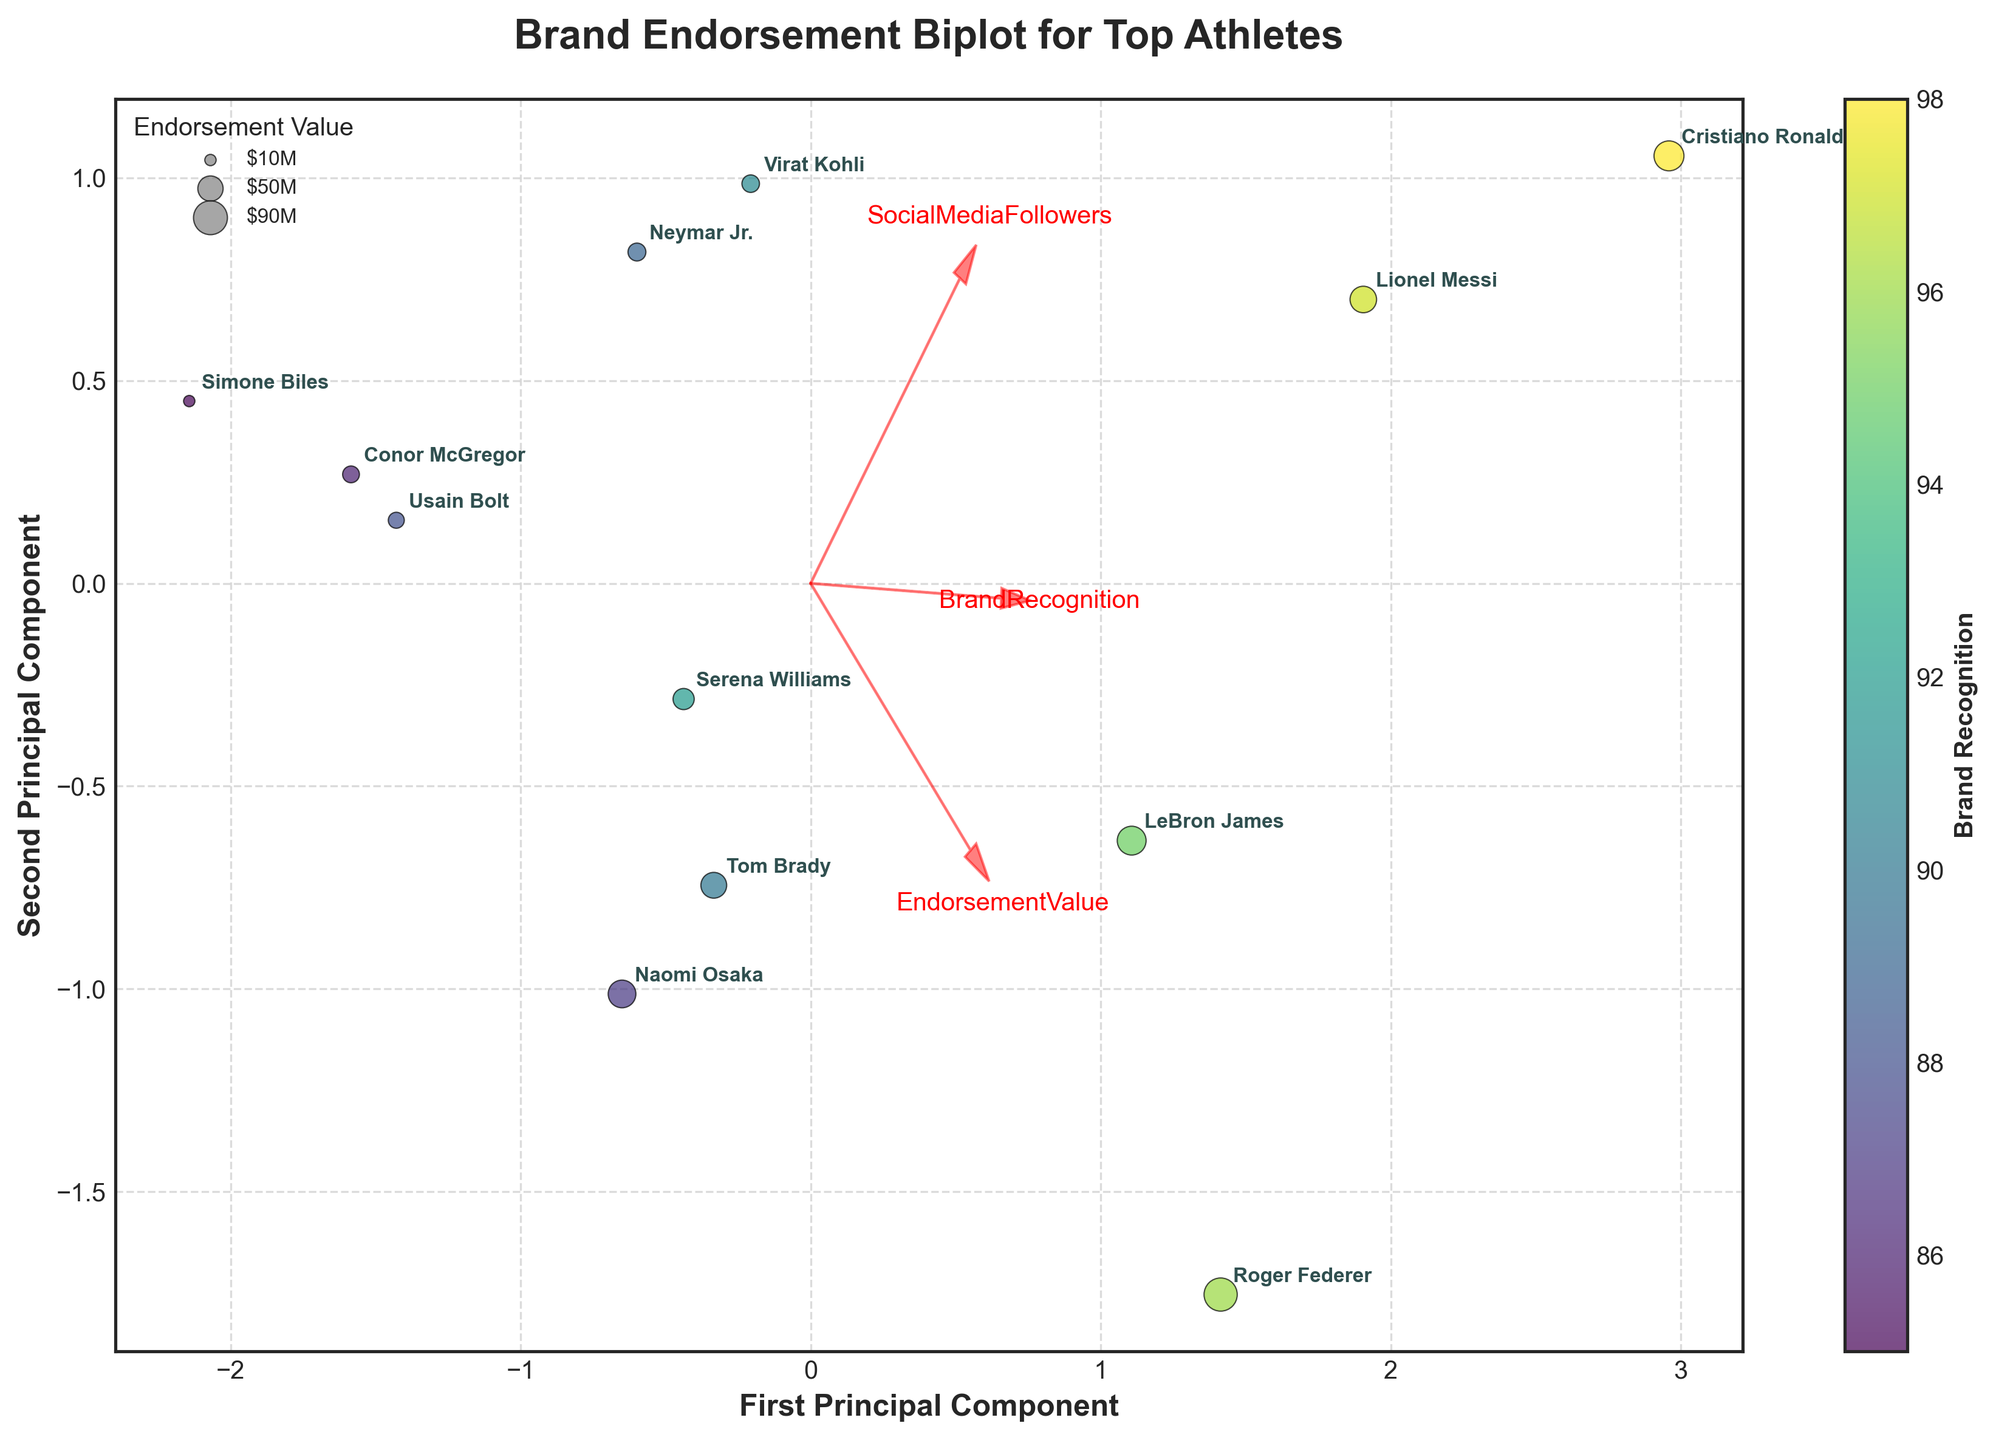what is the title of the plot? The title of the plot is typically located at the top and is intended to provide a clear understanding of what the plot is about. By looking at the figure, it can be seen that the title reads "Brand Endorsement Biplot for Top Athletes".
Answer: Brand Endorsement Biplot for Top Athletes Which athlete has the highest endorsement value? To find the athlete with the highest endorsement value, you need to look for the largest bubble in the plot since the size of the bubbles represents endorsement value. By checking the dataset, Cristiano Ronaldo has an endorsement value of $70M which is the largest among all athletes in the plot.
Answer: Cristiano Ronaldo How many principal components are shown in the biplot? A biplot typically shows two principal components as it is a two-dimensional plot. This is confirmed by looking at the x-axis and y-axis labels which state "First Principal Component" and "Second Principal Component" respectively.
Answer: Two Which sport types show the most variation in principal component space? To assess which sport types show the most variation, observe the spread and clustering of the data points associated with different sport types. Soccer points (Cristiano Ronaldo, Lionel Messi, Neymar Jr., etc.) are spread across a wider area compared to athletes from other sports.
Answer: Soccer What does the color of each data point indicate? The color of each data point represents the Brand Recognition value. This can be inferred from the color bar at the side of the plot which indicates the scale for Brand Recognition.
Answer: Brand Recognition How is 'Endorsement Value' depicted in the plot? The Endorsement Value is depicted by the size of the data points (bubbles). Larger bubbles represent higher endorsement values.
Answer: Bubble size Which athlete has the lowest social media followers in the dataset? By observing the smaller data points in terms of bubble size, Serena Williams stands out with a fewer social media followers of 16 million, relatively less compared to other athletes in the dataset.
Answer: Serena Williams What do the red arrows represent in the biplot? The red arrows in a biplot typically represent feature vectors. They show the direction and strength of the original variables (EndorsementValue, SocialMediaFollowers, BrandRecognition) in the principal component space.
Answer: Feature vectors Which athlete has the highest brand recognition but not the highest endorsement value? By comparing the color intensities and bubble sizes, Roger Federer stands out with a brand recognition value of 96 (highly intense color) but does not have the highest endorsement value.
Answer: Roger Federer Are there any athletes from the same sport that cluster together in the biplot? Observing the distribution, athletes from Soccer like Cristiano Ronaldo, Lionel Messi, and Neymar Jr. are relatively close to each other in the plot, indicating they form a cluster.
Answer: Yes, Soccer athletes 